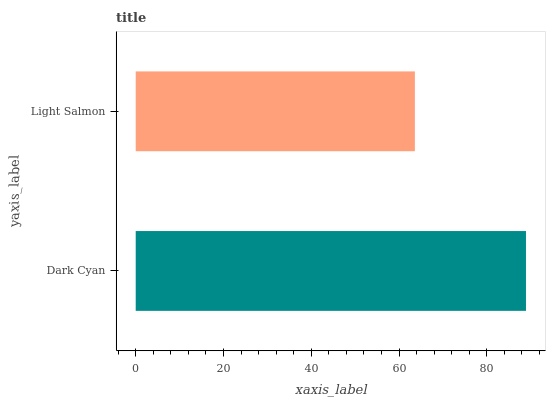Is Light Salmon the minimum?
Answer yes or no. Yes. Is Dark Cyan the maximum?
Answer yes or no. Yes. Is Light Salmon the maximum?
Answer yes or no. No. Is Dark Cyan greater than Light Salmon?
Answer yes or no. Yes. Is Light Salmon less than Dark Cyan?
Answer yes or no. Yes. Is Light Salmon greater than Dark Cyan?
Answer yes or no. No. Is Dark Cyan less than Light Salmon?
Answer yes or no. No. Is Dark Cyan the high median?
Answer yes or no. Yes. Is Light Salmon the low median?
Answer yes or no. Yes. Is Light Salmon the high median?
Answer yes or no. No. Is Dark Cyan the low median?
Answer yes or no. No. 